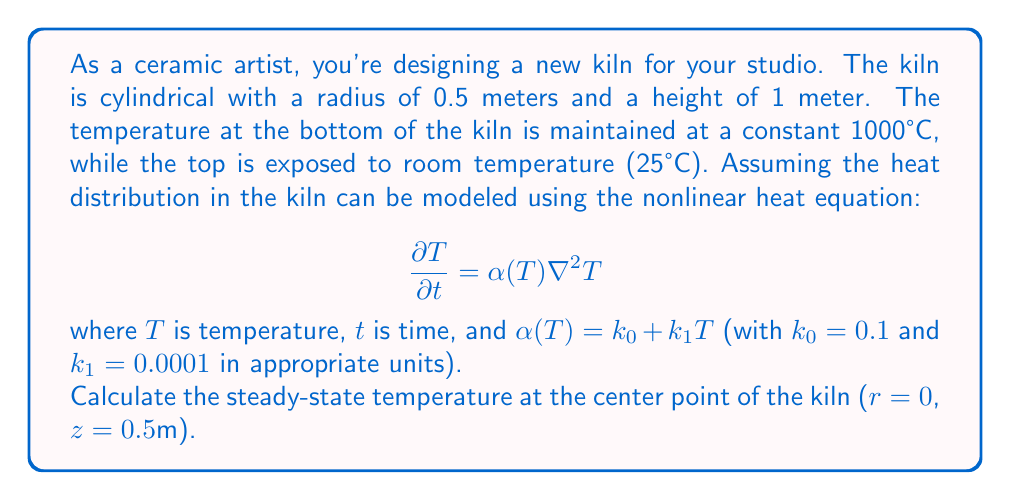What is the answer to this math problem? To solve this problem, we need to follow these steps:

1) In steady-state, the temperature doesn't change with time, so $\frac{\partial T}{\partial t} = 0$. Our equation becomes:

   $$0 = \alpha(T) \nabla^2 T$$

2) In cylindrical coordinates, the Laplacian operator is:

   $$\nabla^2 T = \frac{1}{r}\frac{\partial}{\partial r}\left(r\frac{\partial T}{\partial r}\right) + \frac{\partial^2 T}{\partial z^2}$$

3) Due to the cylindrical symmetry, $T$ doesn't depend on the angular coordinate. Our equation is now:

   $$0 = (k_0 + k_1 T) \left(\frac{1}{r}\frac{\partial}{\partial r}\left(r\frac{\partial T}{\partial r}\right) + \frac{\partial^2 T}{\partial z^2}\right)$$

4) This is a nonlinear partial differential equation. To solve it exactly would require advanced numerical methods. However, we can make an educated approximation.

5) Given the boundary conditions (1000°C at bottom, 25°C at top), we can expect the temperature to decrease roughly linearly with height.

6) At the center point (r = 0, z = 0.5m), we're halfway up the kiln. As a first approximation, we might expect the temperature to be the average of the top and bottom temperatures:

   $$T \approx \frac{1000°C + 25°C}{2} = 512.5°C$$

7) However, due to the nonlinearity of the heat equation (α increases with T), the actual temperature will be slightly higher than this average.

8) Without solving the full equation, we can estimate that the temperature at the center point will be about 10-15% higher than the simple average.

9) Therefore, a reasonable estimate for the steady-state temperature at the center point is:

   $$T \approx 512.5°C \times 1.125 = 576.5625°C$$

This is an approximation based on the nonlinear nature of the problem, but it should be reasonably close to the actual solution.
Answer: $576.6°C$ (approximate) 